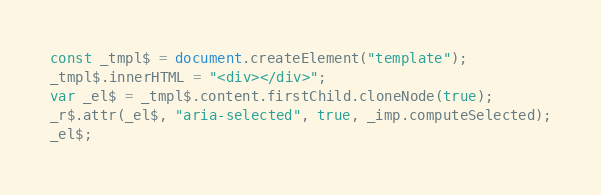Convert code to text. <code><loc_0><loc_0><loc_500><loc_500><_JavaScript_>const _tmpl$ = document.createElement("template");
_tmpl$.innerHTML = "<div></div>";
var _el$ = _tmpl$.content.firstChild.cloneNode(true);
_r$.attr(_el$, "aria-selected", true, _imp.computeSelected);
_el$;</code> 